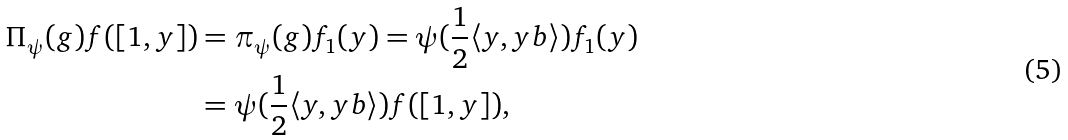<formula> <loc_0><loc_0><loc_500><loc_500>\Pi _ { \psi } ( g ) f ( [ 1 , y ] ) & = \pi _ { \psi } ( g ) f _ { 1 } ( y ) = \psi ( \frac { 1 } { 2 } \langle y , y b \rangle ) f _ { 1 } ( y ) \\ & = \psi ( \frac { 1 } { 2 } \langle y , y b \rangle ) f ( [ 1 , y ] ) ,</formula> 